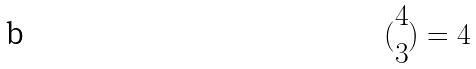Convert formula to latex. <formula><loc_0><loc_0><loc_500><loc_500>( \begin{matrix} 4 \\ 3 \end{matrix} ) = 4</formula> 